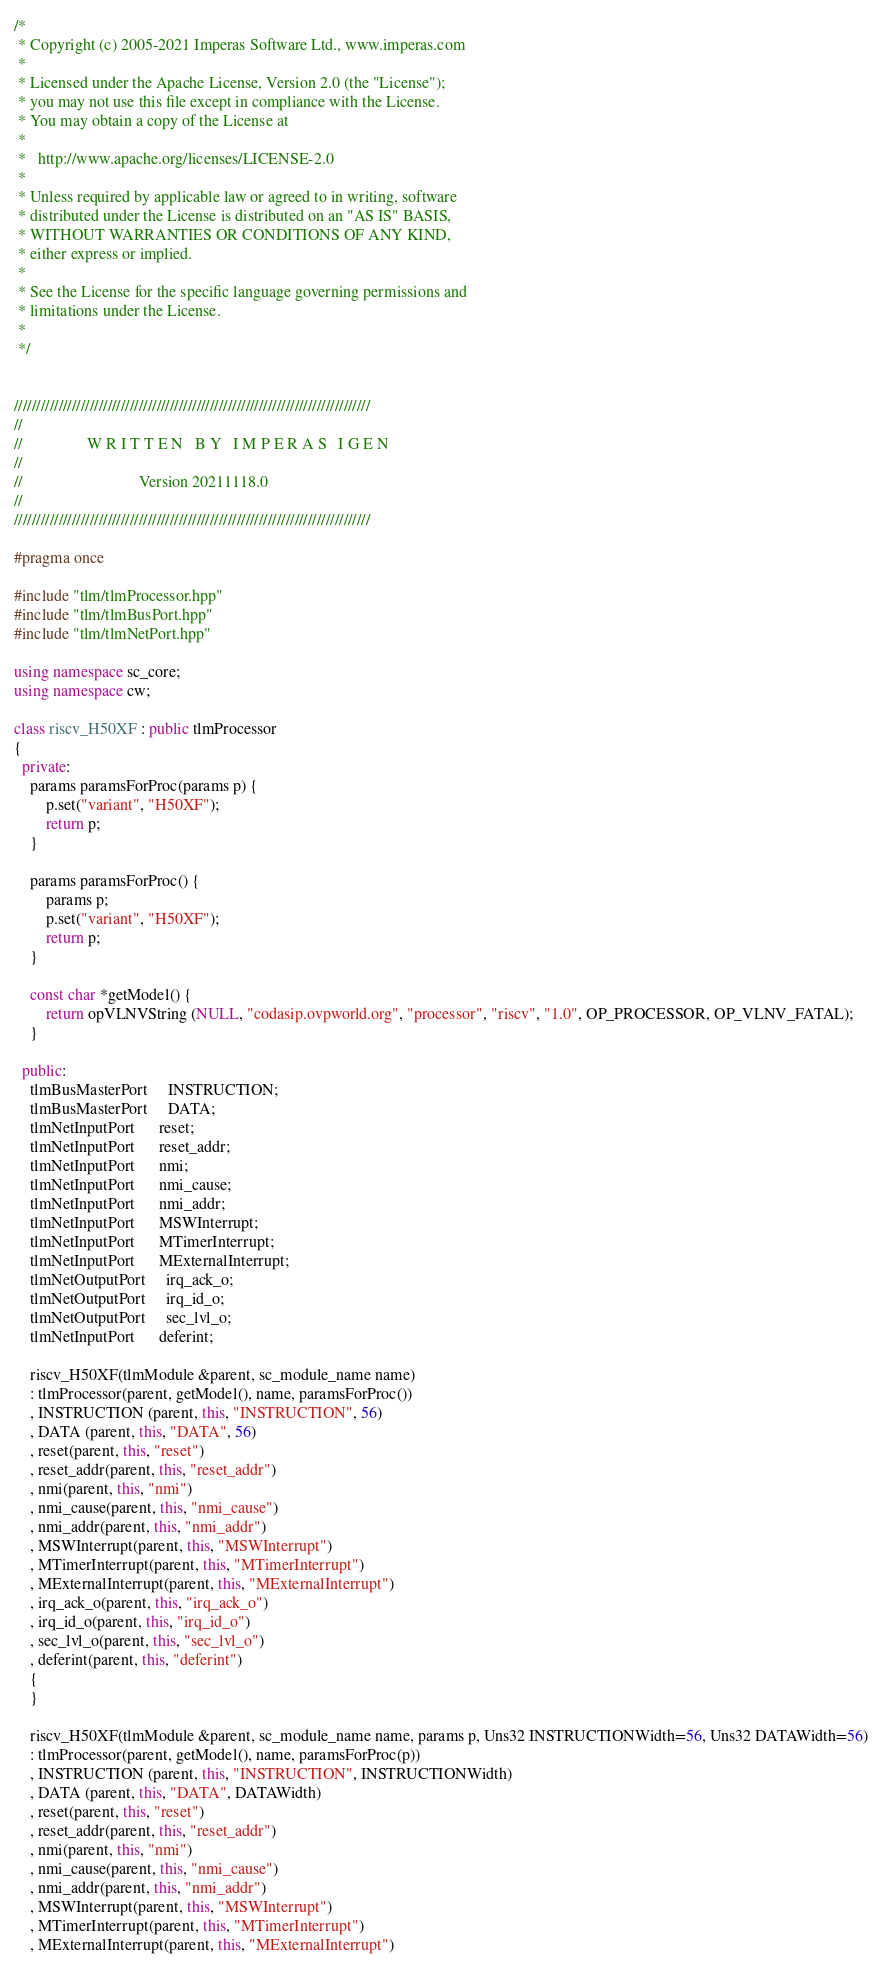Convert code to text. <code><loc_0><loc_0><loc_500><loc_500><_C++_>/*
 * Copyright (c) 2005-2021 Imperas Software Ltd., www.imperas.com
 *
 * Licensed under the Apache License, Version 2.0 (the "License");
 * you may not use this file except in compliance with the License.
 * You may obtain a copy of the License at
 *
 *   http://www.apache.org/licenses/LICENSE-2.0
 *
 * Unless required by applicable law or agreed to in writing, software
 * distributed under the License is distributed on an "AS IS" BASIS,
 * WITHOUT WARRANTIES OR CONDITIONS OF ANY KIND,
 * either express or implied.
 *
 * See the License for the specific language governing permissions and
 * limitations under the License.
 *
 */


////////////////////////////////////////////////////////////////////////////////
//
//                W R I T T E N   B Y   I M P E R A S   I G E N
//
//                             Version 20211118.0
//
////////////////////////////////////////////////////////////////////////////////

#pragma once

#include "tlm/tlmProcessor.hpp"
#include "tlm/tlmBusPort.hpp"
#include "tlm/tlmNetPort.hpp"

using namespace sc_core;
using namespace cw;

class riscv_H50XF : public tlmProcessor
{
  private:
    params paramsForProc(params p) {
        p.set("variant", "H50XF");
        return p;
    }

    params paramsForProc() {
        params p;
        p.set("variant", "H50XF");
        return p;
    }

    const char *getModel() {
        return opVLNVString (NULL, "codasip.ovpworld.org", "processor", "riscv", "1.0", OP_PROCESSOR, OP_VLNV_FATAL);
    }

  public:
    tlmBusMasterPort     INSTRUCTION;
    tlmBusMasterPort     DATA;
    tlmNetInputPort      reset;
    tlmNetInputPort      reset_addr;
    tlmNetInputPort      nmi;
    tlmNetInputPort      nmi_cause;
    tlmNetInputPort      nmi_addr;
    tlmNetInputPort      MSWInterrupt;
    tlmNetInputPort      MTimerInterrupt;
    tlmNetInputPort      MExternalInterrupt;
    tlmNetOutputPort     irq_ack_o;
    tlmNetOutputPort     irq_id_o;
    tlmNetOutputPort     sec_lvl_o;
    tlmNetInputPort      deferint;

    riscv_H50XF(tlmModule &parent, sc_module_name name)
    : tlmProcessor(parent, getModel(), name, paramsForProc())
    , INSTRUCTION (parent, this, "INSTRUCTION", 56)
    , DATA (parent, this, "DATA", 56)
    , reset(parent, this, "reset")
    , reset_addr(parent, this, "reset_addr")
    , nmi(parent, this, "nmi")
    , nmi_cause(parent, this, "nmi_cause")
    , nmi_addr(parent, this, "nmi_addr")
    , MSWInterrupt(parent, this, "MSWInterrupt")
    , MTimerInterrupt(parent, this, "MTimerInterrupt")
    , MExternalInterrupt(parent, this, "MExternalInterrupt")
    , irq_ack_o(parent, this, "irq_ack_o")
    , irq_id_o(parent, this, "irq_id_o")
    , sec_lvl_o(parent, this, "sec_lvl_o")
    , deferint(parent, this, "deferint")
    {
    }

    riscv_H50XF(tlmModule &parent, sc_module_name name, params p, Uns32 INSTRUCTIONWidth=56, Uns32 DATAWidth=56)
    : tlmProcessor(parent, getModel(), name, paramsForProc(p))
    , INSTRUCTION (parent, this, "INSTRUCTION", INSTRUCTIONWidth)
    , DATA (parent, this, "DATA", DATAWidth)
    , reset(parent, this, "reset")
    , reset_addr(parent, this, "reset_addr")
    , nmi(parent, this, "nmi")
    , nmi_cause(parent, this, "nmi_cause")
    , nmi_addr(parent, this, "nmi_addr")
    , MSWInterrupt(parent, this, "MSWInterrupt")
    , MTimerInterrupt(parent, this, "MTimerInterrupt")
    , MExternalInterrupt(parent, this, "MExternalInterrupt")</code> 